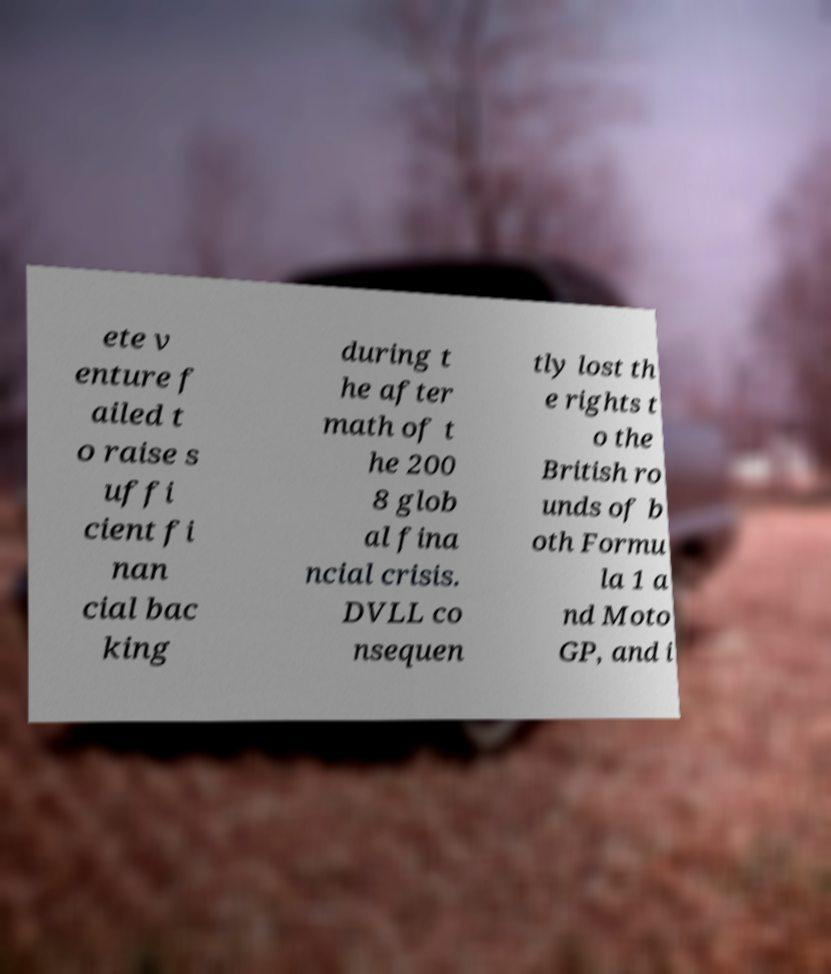I need the written content from this picture converted into text. Can you do that? ete v enture f ailed t o raise s uffi cient fi nan cial bac king during t he after math of t he 200 8 glob al fina ncial crisis. DVLL co nsequen tly lost th e rights t o the British ro unds of b oth Formu la 1 a nd Moto GP, and i 